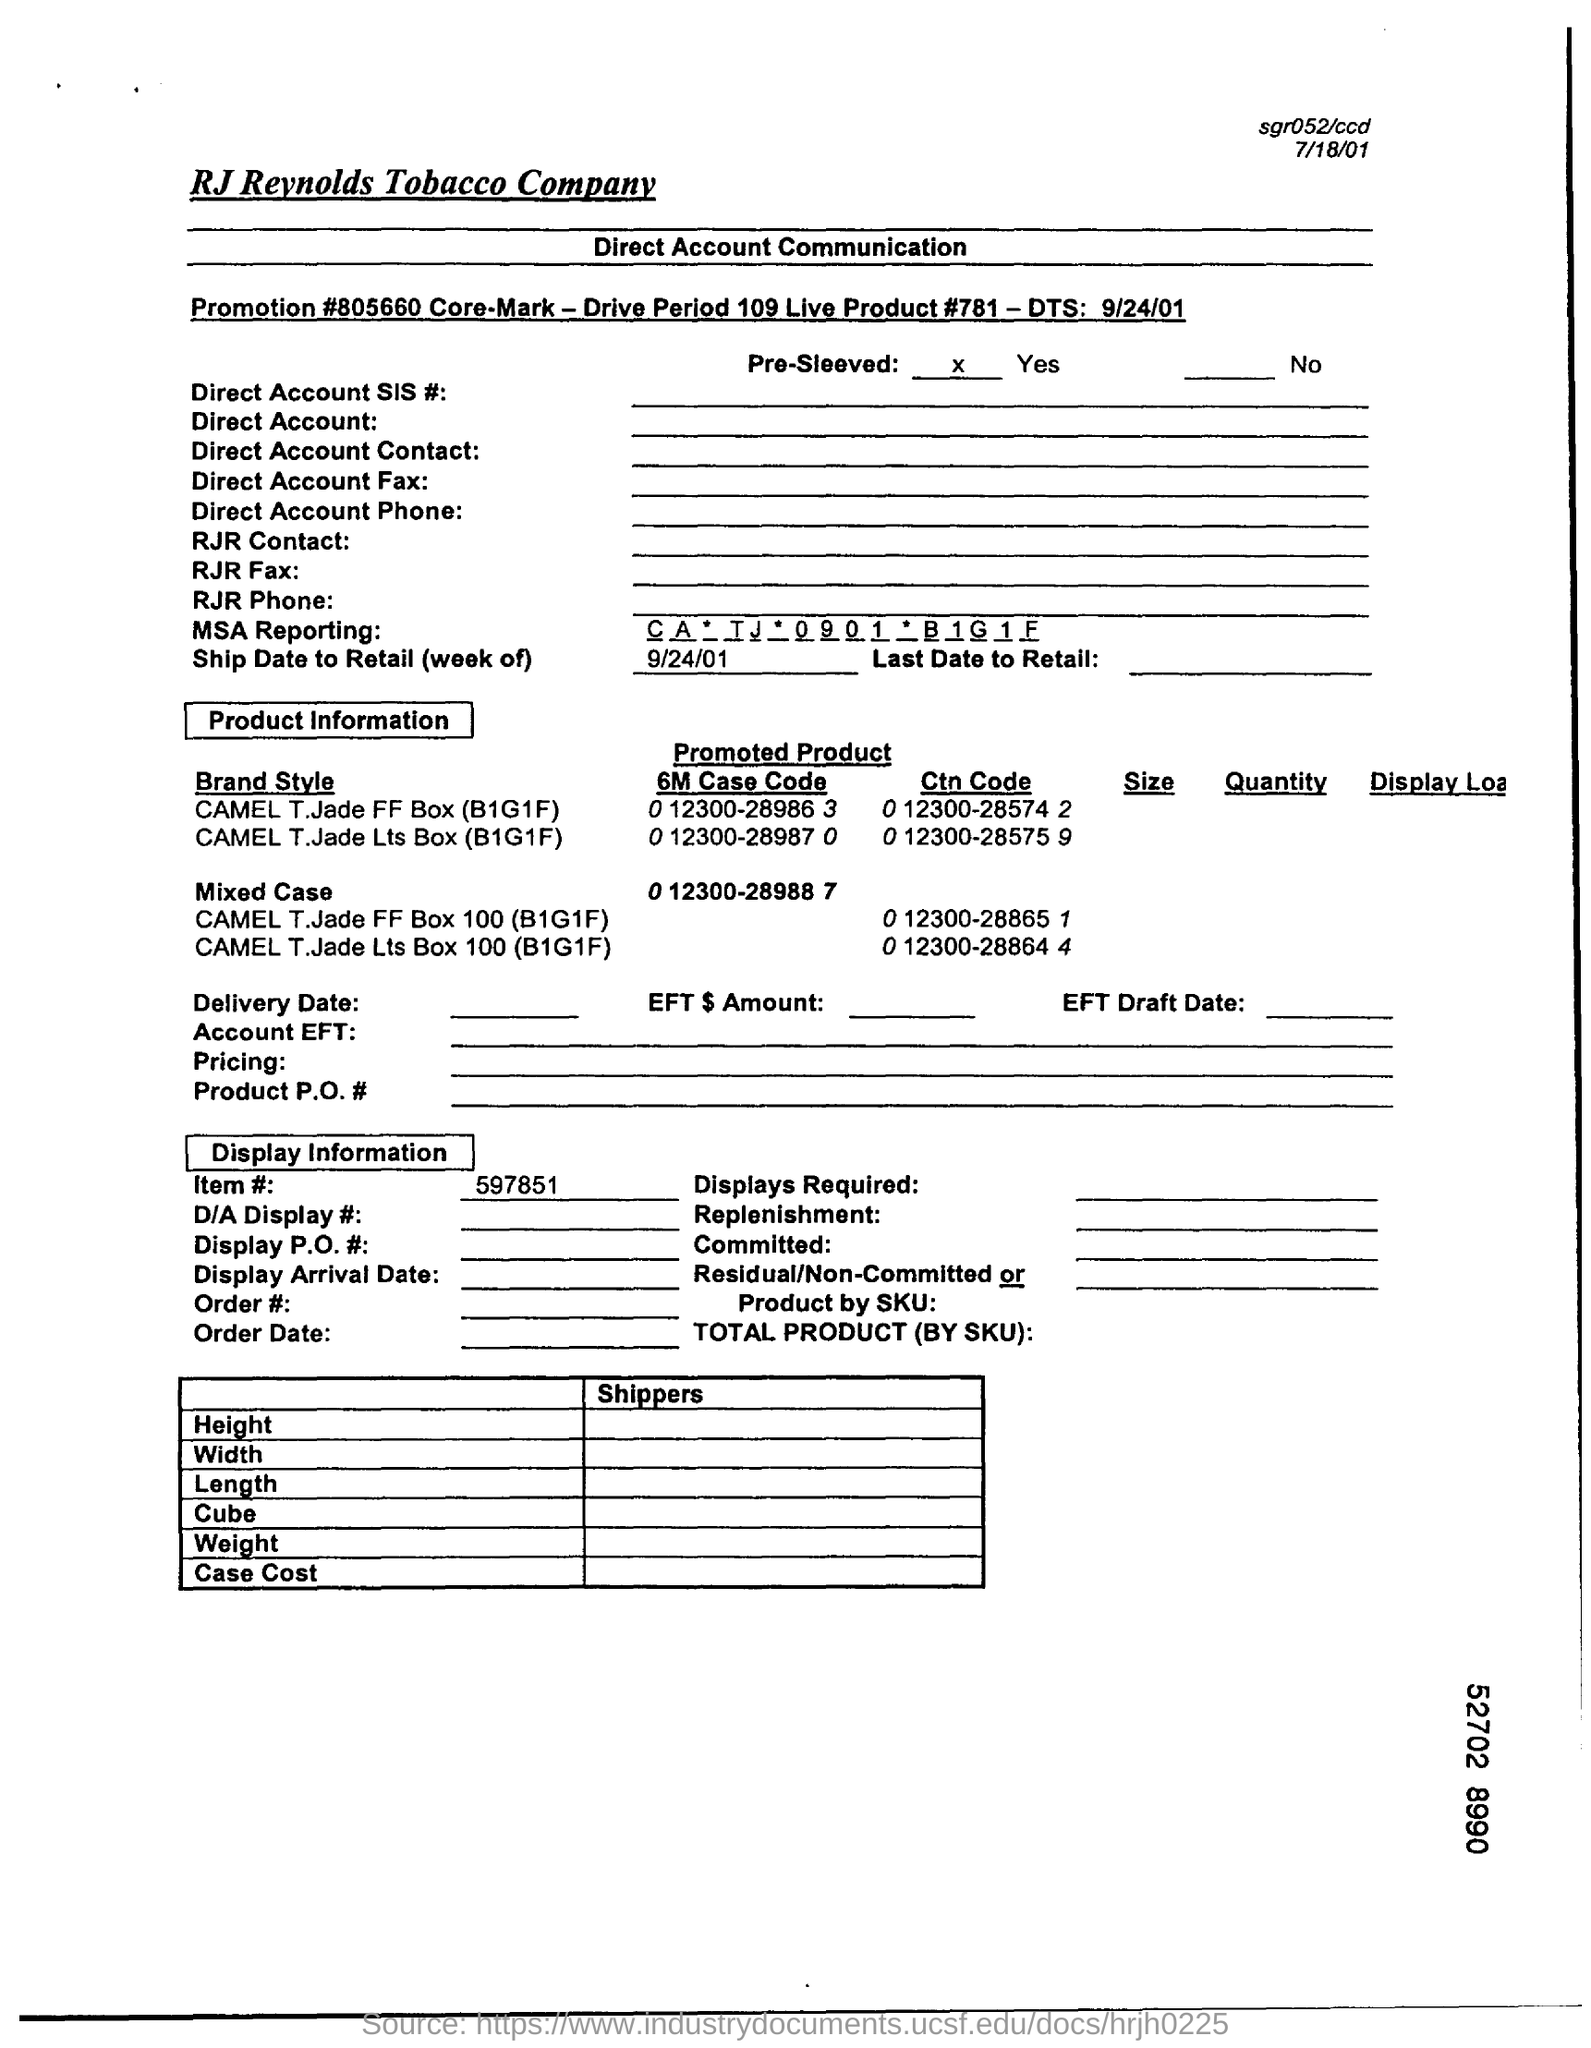List a handful of essential elements in this visual. This value is for the reporting of MSA (Medical, Scientific, and Academic) information, with the abbreviation CA denoting the company, TJ denoting the topic, and the year 2009 and the month of January being specified, followed by the code B1G1F, which is unknown. The product is pre-sleeved. The specified date in "Ship Date to Retail (week of)" is 9/24/01. The first "Brand Style" product under the title "Product Information" is the "CAMEL T.Jade FF Box (B1G1F). The promotion number written in the first subheading of the document is 805660. 